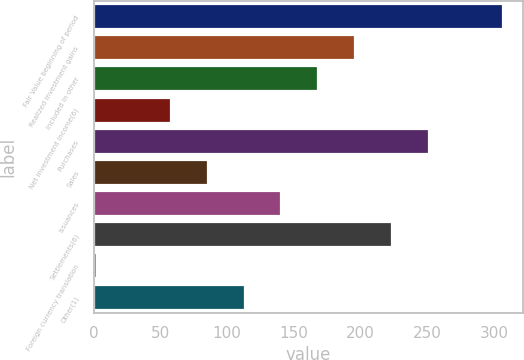Convert chart to OTSL. <chart><loc_0><loc_0><loc_500><loc_500><bar_chart><fcel>Fair Value beginning of period<fcel>Realized investment gains<fcel>Included in other<fcel>Net investment income(6)<fcel>Purchases<fcel>Sales<fcel>Issuances<fcel>Settlements(6)<fcel>Foreign currency translation<fcel>Other(1)<nl><fcel>306.6<fcel>196.08<fcel>168.45<fcel>57.93<fcel>251.34<fcel>85.56<fcel>140.82<fcel>223.71<fcel>2.67<fcel>113.19<nl></chart> 